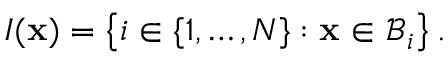Convert formula to latex. <formula><loc_0><loc_0><loc_500><loc_500>I ( x ) = \left \{ i \in \{ 1 , \dots , N \} \colon x \in \mathcal { B } _ { i } \right \} .</formula> 